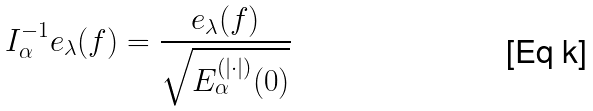<formula> <loc_0><loc_0><loc_500><loc_500>I _ { \alpha } ^ { - 1 } e _ { \lambda } ( f ) = \frac { e _ { \lambda } ( f ) } { \sqrt { E _ { \alpha } ^ { ( | \cdot | ) } ( 0 ) } }</formula> 